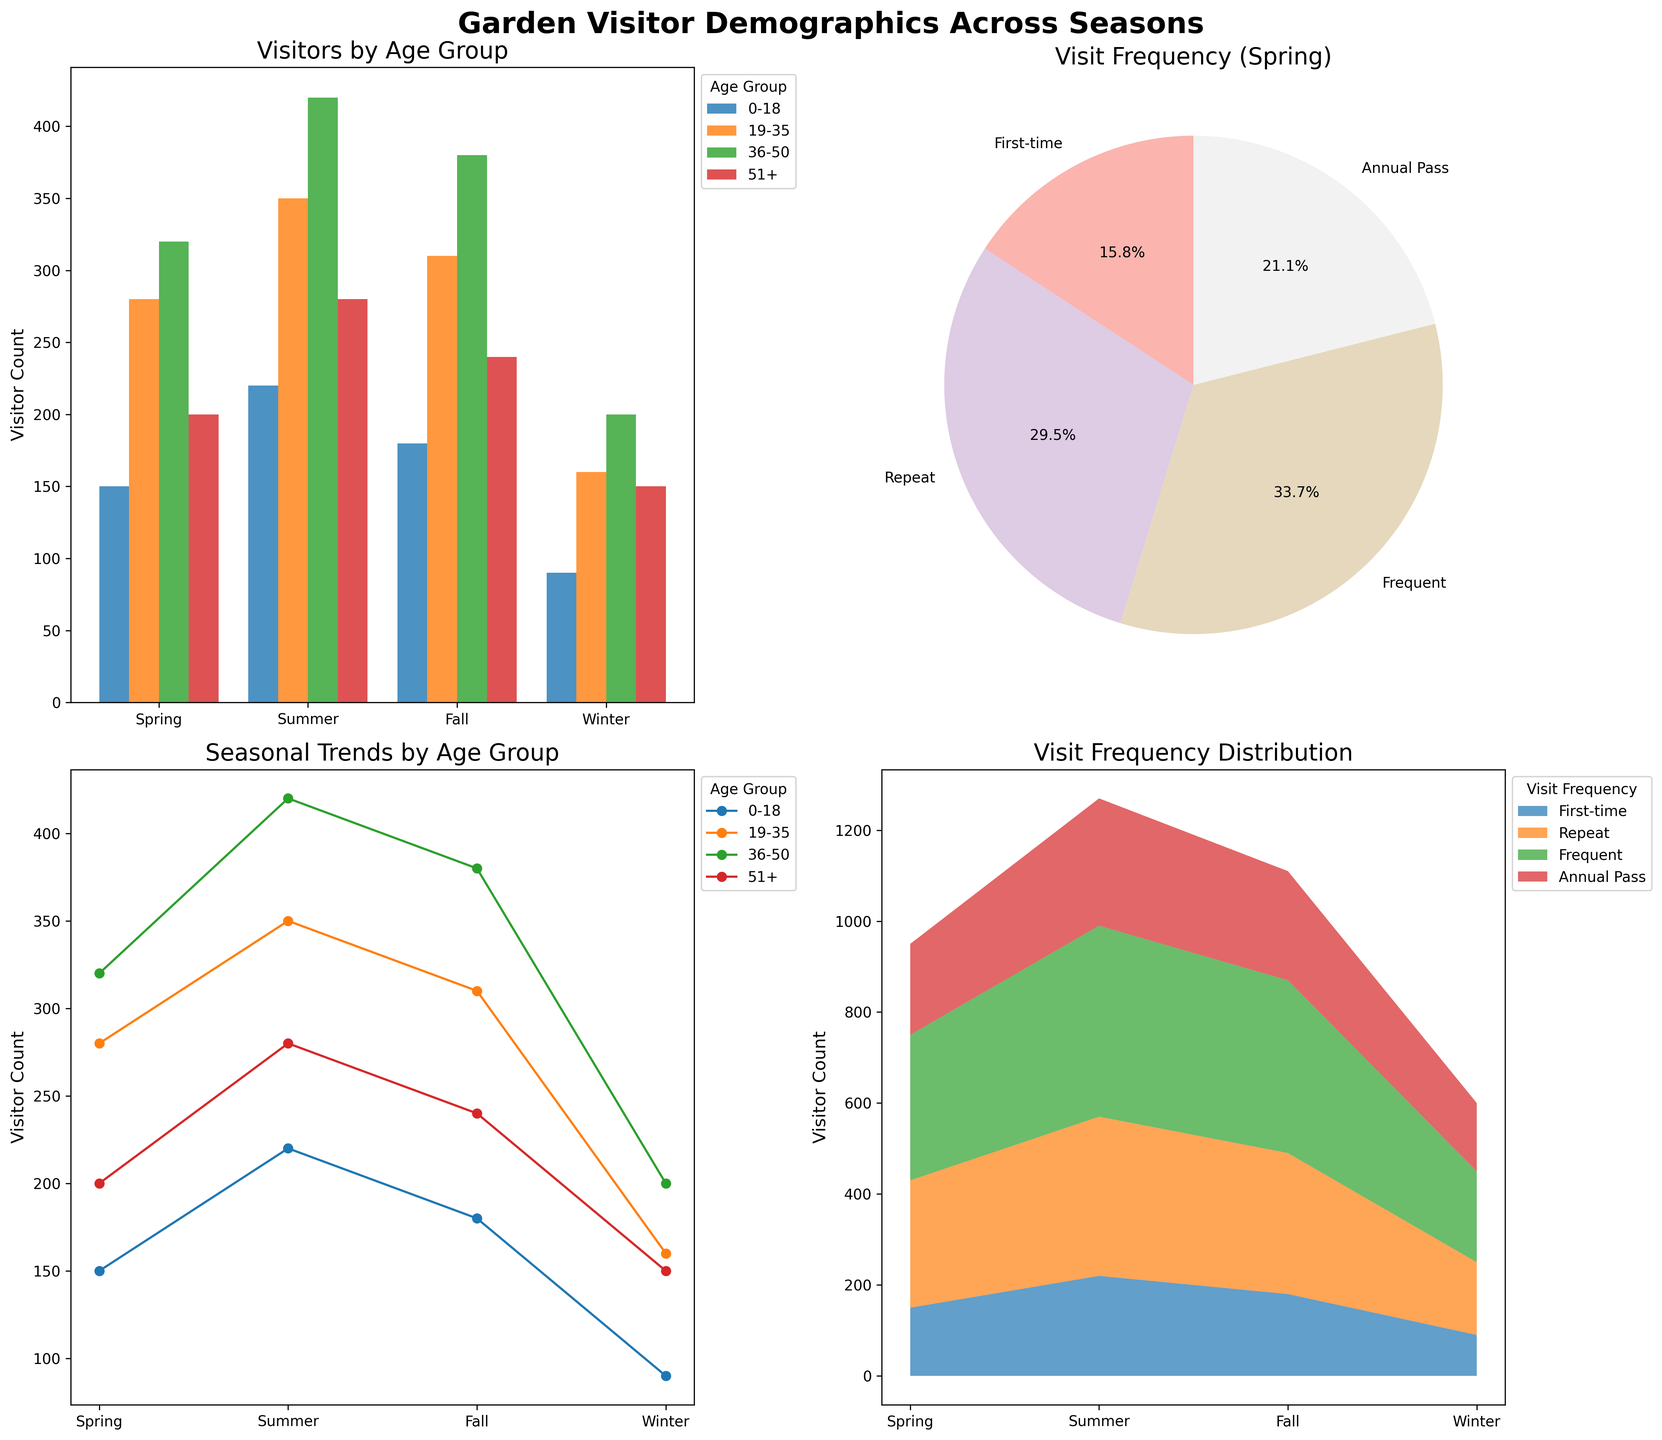What season has the highest total visitor count? To find the season with the highest total visitor count, we need to sum up the visitor counts for each season across all age groups and visit frequencies and then compare these totals. By summing the visitor counts seasonally, Spring: (150 + 280 + 320 + 200) = 950; Summer: (220 + 350 + 420 + 280) = 1270; Fall: (180 + 310 + 380 + 240) = 1110; Winter: (90 + 160 + 200 + 150) = 600. Summer has the highest total.
Answer: Summer Which age group had the most visitors in Fall? To determine the age group with the most visitors in Fall, locate the Fall season in the bar chart (Subplot 1) or line plot (Subplot 3), and compare the visitor counts across different age groups. The visitor counts for Fall are: 0-18: 180, 19-35: 310, 36-50: 380, 51+: 240. The age group with the highest count is 36-50.
Answer: 36-50 What's the percentage of first-time visitors in Spring? Reference the pie chart (Subplot 2) for visit frequency distributions in Spring. Locate the "First-time" segment and read the associated percentage. The pie chart indicates the percentage directly.
Answer: 19.7% How does the visitor count for age group 51+ change from Summer to Winter? From the line plot (Subplot 3), trace the visitor counts for the age group 51+ between Summer and Winter. In Summer, the count is 280; in Winter, it's 150. Calculate the change: 280 - 150 = 130.
Answer: Decreases by 130 Which visit frequency has the smallest share in Spring? Look at the pie chart (Subplot 2) for Spring and identify the segment with the smallest percentage. The pie chart provides a visual representation of each frequency with respective percentages.
Answer: First-time How do the number of repeat visitors compare between Spring and Fall? Compare the visitor counts for the "Repeat" visit frequency in Spring and Fall from Subplot 1 or by adding counts related to "Repeat" from the dataset. Spring Repeat visitors: 280; Fall Repeat visitors: 310.
Answer: Fall has more repeat visitors How many more visitors are there in the age group 0-18 in Summer compared to Winter? Compare the visitor counts for 0-18 in Summer and Winter using the bar chart (Subplot 1) or line plot (Subplot 3). In Summer, the count is 220; in Winter, it's 90. Calculate the difference: 220 - 90 = 130.
Answer: 130 Which season shows the greatest variation in visitor numbers between the age groups? To determine the season with the greatest variation, analyze the bar chart (Subplot 1) and identify the season with the wide range of visitor counts among age groups. Calculate the difference between the highest and lowest counts within each season: Spring (320 - 150) = 170; Summer (420 - 220) = 200; Fall (380 - 180) = 200; Winter (200 - 90) = 110.
Answer: Summer/Fall What trend can be observed for frequent visitors across the seasons? From the line plot (Subplot 3), trace the visitor counts for "Frequent" visitors across all seasons. Observe the changes: Spring: 320; Summer: 420; Fall: 380; Winter: 200. The trend shows an increase until Summer, a slight drop in Fall, and a significant drop in Winter.
Answer: Increases in Spring and Summer, then declines in Fall and Winter 